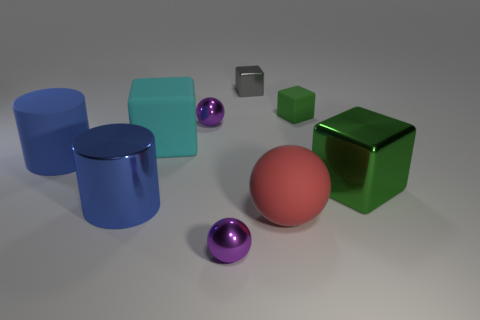The small purple sphere that is in front of the matte cube on the left side of the metal block behind the tiny rubber cube is made of what material?
Offer a terse response. Metal. What number of other things are the same material as the red sphere?
Keep it short and to the point. 3. How many matte cubes are in front of the tiny purple object behind the large ball?
Your answer should be very brief. 1. What number of balls are either cyan rubber objects or tiny purple metal objects?
Keep it short and to the point. 2. What is the color of the sphere that is both left of the small gray shiny block and in front of the big blue metal cylinder?
Offer a terse response. Purple. Is there anything else of the same color as the tiny matte thing?
Your answer should be compact. Yes. What color is the metal cube that is to the right of the green object behind the large cyan matte object?
Ensure brevity in your answer.  Green. Is the size of the blue rubber cylinder the same as the matte ball?
Give a very brief answer. Yes. Do the big cube on the left side of the green matte thing and the big cylinder that is to the left of the big blue shiny cylinder have the same material?
Offer a very short reply. Yes. What is the shape of the green rubber thing that is right of the shiny block that is behind the small purple metallic thing behind the large red rubber object?
Make the answer very short. Cube. 